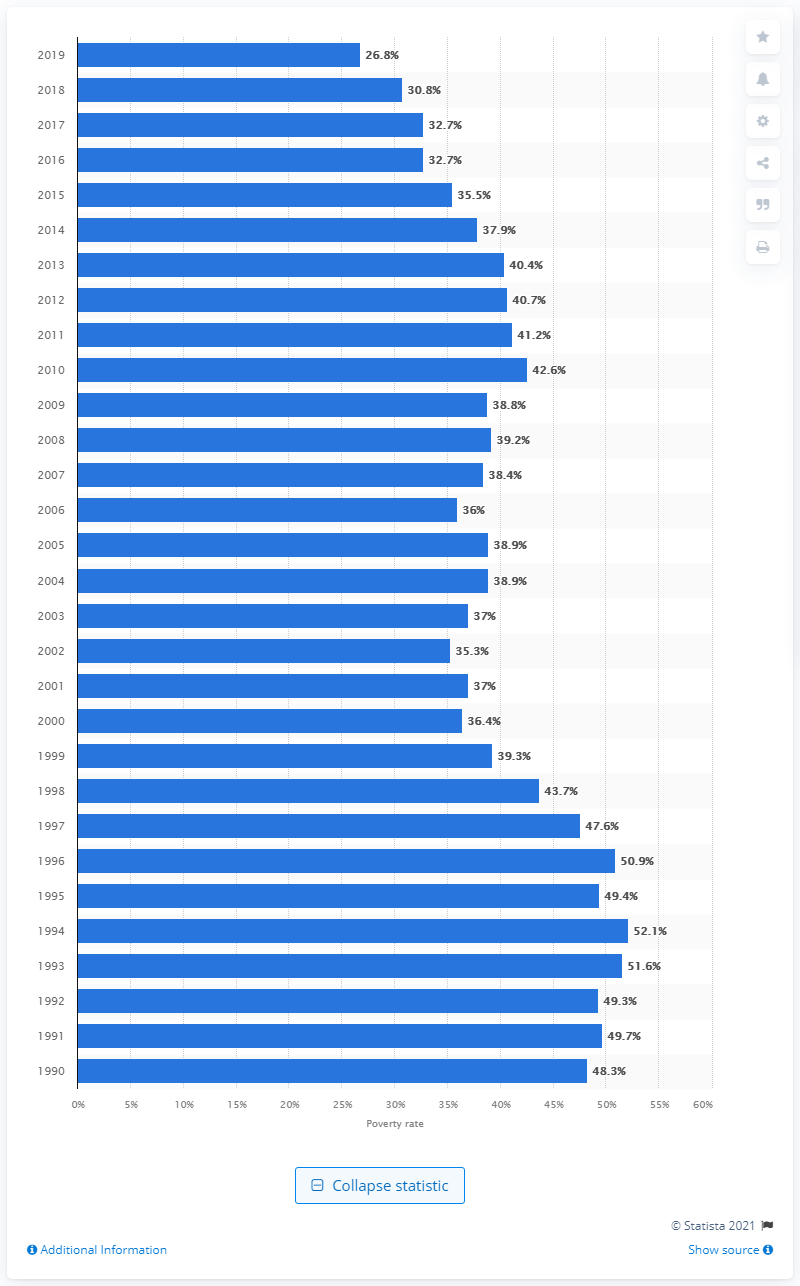Draw attention to some important aspects in this diagram. In 2019, approximately 26.8% of Hispanic families with a single mother were living in poverty, according to recent data. 